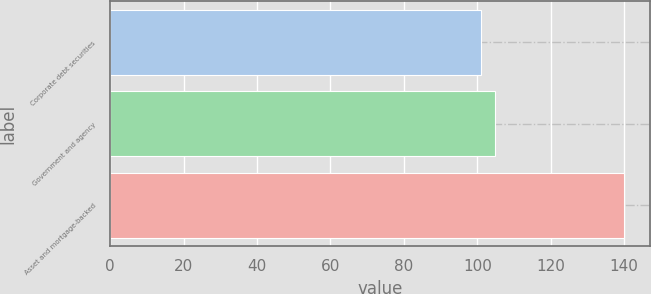Convert chart to OTSL. <chart><loc_0><loc_0><loc_500><loc_500><bar_chart><fcel>Corporate debt securities<fcel>Government and agency<fcel>Asset and mortgage-backed<nl><fcel>101<fcel>104.9<fcel>140<nl></chart> 